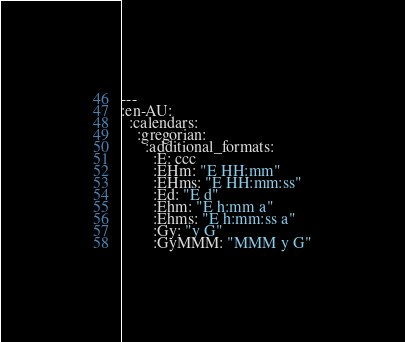Convert code to text. <code><loc_0><loc_0><loc_500><loc_500><_YAML_>--- 
:en-AU: 
  :calendars: 
    :gregorian: 
      :additional_formats: 
        :E: ccc
        :EHm: "E HH:mm"
        :EHms: "E HH:mm:ss"
        :Ed: "E d"
        :Ehm: "E h:mm a"
        :Ehms: "E h:mm:ss a"
        :Gy: "y G"
        :GyMMM: "MMM y G"</code> 